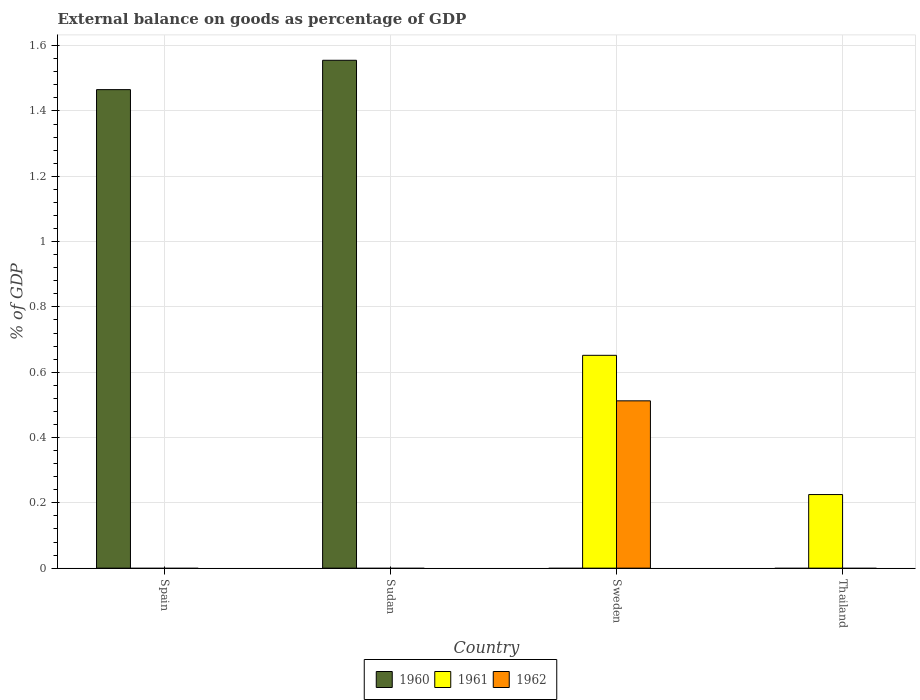How many bars are there on the 2nd tick from the left?
Make the answer very short. 1. How many bars are there on the 4th tick from the right?
Ensure brevity in your answer.  1. In how many cases, is the number of bars for a given country not equal to the number of legend labels?
Make the answer very short. 4. Across all countries, what is the maximum external balance on goods as percentage of GDP in 1960?
Offer a very short reply. 1.56. Across all countries, what is the minimum external balance on goods as percentage of GDP in 1961?
Your answer should be compact. 0. In which country was the external balance on goods as percentage of GDP in 1962 maximum?
Keep it short and to the point. Sweden. What is the total external balance on goods as percentage of GDP in 1960 in the graph?
Your response must be concise. 3.02. What is the difference between the external balance on goods as percentage of GDP in 1960 in Thailand and the external balance on goods as percentage of GDP in 1961 in Sudan?
Your response must be concise. 0. What is the average external balance on goods as percentage of GDP in 1960 per country?
Provide a succinct answer. 0.76. What is the difference between the external balance on goods as percentage of GDP of/in 1961 and external balance on goods as percentage of GDP of/in 1962 in Sweden?
Offer a terse response. 0.14. In how many countries, is the external balance on goods as percentage of GDP in 1961 greater than 0.2 %?
Offer a terse response. 2. What is the ratio of the external balance on goods as percentage of GDP in 1961 in Sweden to that in Thailand?
Offer a very short reply. 2.89. What is the difference between the highest and the lowest external balance on goods as percentage of GDP in 1960?
Provide a short and direct response. 1.56. In how many countries, is the external balance on goods as percentage of GDP in 1961 greater than the average external balance on goods as percentage of GDP in 1961 taken over all countries?
Provide a succinct answer. 2. Is it the case that in every country, the sum of the external balance on goods as percentage of GDP in 1962 and external balance on goods as percentage of GDP in 1961 is greater than the external balance on goods as percentage of GDP in 1960?
Provide a short and direct response. No. Are the values on the major ticks of Y-axis written in scientific E-notation?
Offer a terse response. No. How many legend labels are there?
Your answer should be very brief. 3. What is the title of the graph?
Offer a very short reply. External balance on goods as percentage of GDP. Does "1988" appear as one of the legend labels in the graph?
Offer a terse response. No. What is the label or title of the Y-axis?
Your answer should be compact. % of GDP. What is the % of GDP in 1960 in Spain?
Offer a terse response. 1.47. What is the % of GDP in 1962 in Spain?
Offer a very short reply. 0. What is the % of GDP in 1960 in Sudan?
Your answer should be very brief. 1.56. What is the % of GDP of 1962 in Sudan?
Provide a short and direct response. 0. What is the % of GDP of 1960 in Sweden?
Ensure brevity in your answer.  0. What is the % of GDP in 1961 in Sweden?
Ensure brevity in your answer.  0.65. What is the % of GDP in 1962 in Sweden?
Ensure brevity in your answer.  0.51. What is the % of GDP in 1961 in Thailand?
Give a very brief answer. 0.23. What is the % of GDP in 1962 in Thailand?
Offer a very short reply. 0. Across all countries, what is the maximum % of GDP in 1960?
Provide a short and direct response. 1.56. Across all countries, what is the maximum % of GDP of 1961?
Your response must be concise. 0.65. Across all countries, what is the maximum % of GDP in 1962?
Keep it short and to the point. 0.51. Across all countries, what is the minimum % of GDP in 1960?
Ensure brevity in your answer.  0. What is the total % of GDP of 1960 in the graph?
Your response must be concise. 3.02. What is the total % of GDP in 1961 in the graph?
Provide a succinct answer. 0.88. What is the total % of GDP of 1962 in the graph?
Offer a very short reply. 0.51. What is the difference between the % of GDP in 1960 in Spain and that in Sudan?
Ensure brevity in your answer.  -0.09. What is the difference between the % of GDP in 1961 in Sweden and that in Thailand?
Offer a terse response. 0.43. What is the difference between the % of GDP of 1960 in Spain and the % of GDP of 1961 in Sweden?
Keep it short and to the point. 0.81. What is the difference between the % of GDP of 1960 in Spain and the % of GDP of 1962 in Sweden?
Provide a short and direct response. 0.95. What is the difference between the % of GDP of 1960 in Spain and the % of GDP of 1961 in Thailand?
Provide a succinct answer. 1.24. What is the difference between the % of GDP of 1960 in Sudan and the % of GDP of 1961 in Sweden?
Keep it short and to the point. 0.9. What is the difference between the % of GDP in 1960 in Sudan and the % of GDP in 1962 in Sweden?
Keep it short and to the point. 1.04. What is the difference between the % of GDP of 1960 in Sudan and the % of GDP of 1961 in Thailand?
Make the answer very short. 1.33. What is the average % of GDP in 1960 per country?
Offer a terse response. 0.76. What is the average % of GDP in 1961 per country?
Offer a terse response. 0.22. What is the average % of GDP of 1962 per country?
Your answer should be compact. 0.13. What is the difference between the % of GDP in 1961 and % of GDP in 1962 in Sweden?
Make the answer very short. 0.14. What is the ratio of the % of GDP in 1960 in Spain to that in Sudan?
Your answer should be very brief. 0.94. What is the ratio of the % of GDP in 1961 in Sweden to that in Thailand?
Give a very brief answer. 2.89. What is the difference between the highest and the lowest % of GDP of 1960?
Keep it short and to the point. 1.56. What is the difference between the highest and the lowest % of GDP of 1961?
Provide a succinct answer. 0.65. What is the difference between the highest and the lowest % of GDP in 1962?
Make the answer very short. 0.51. 